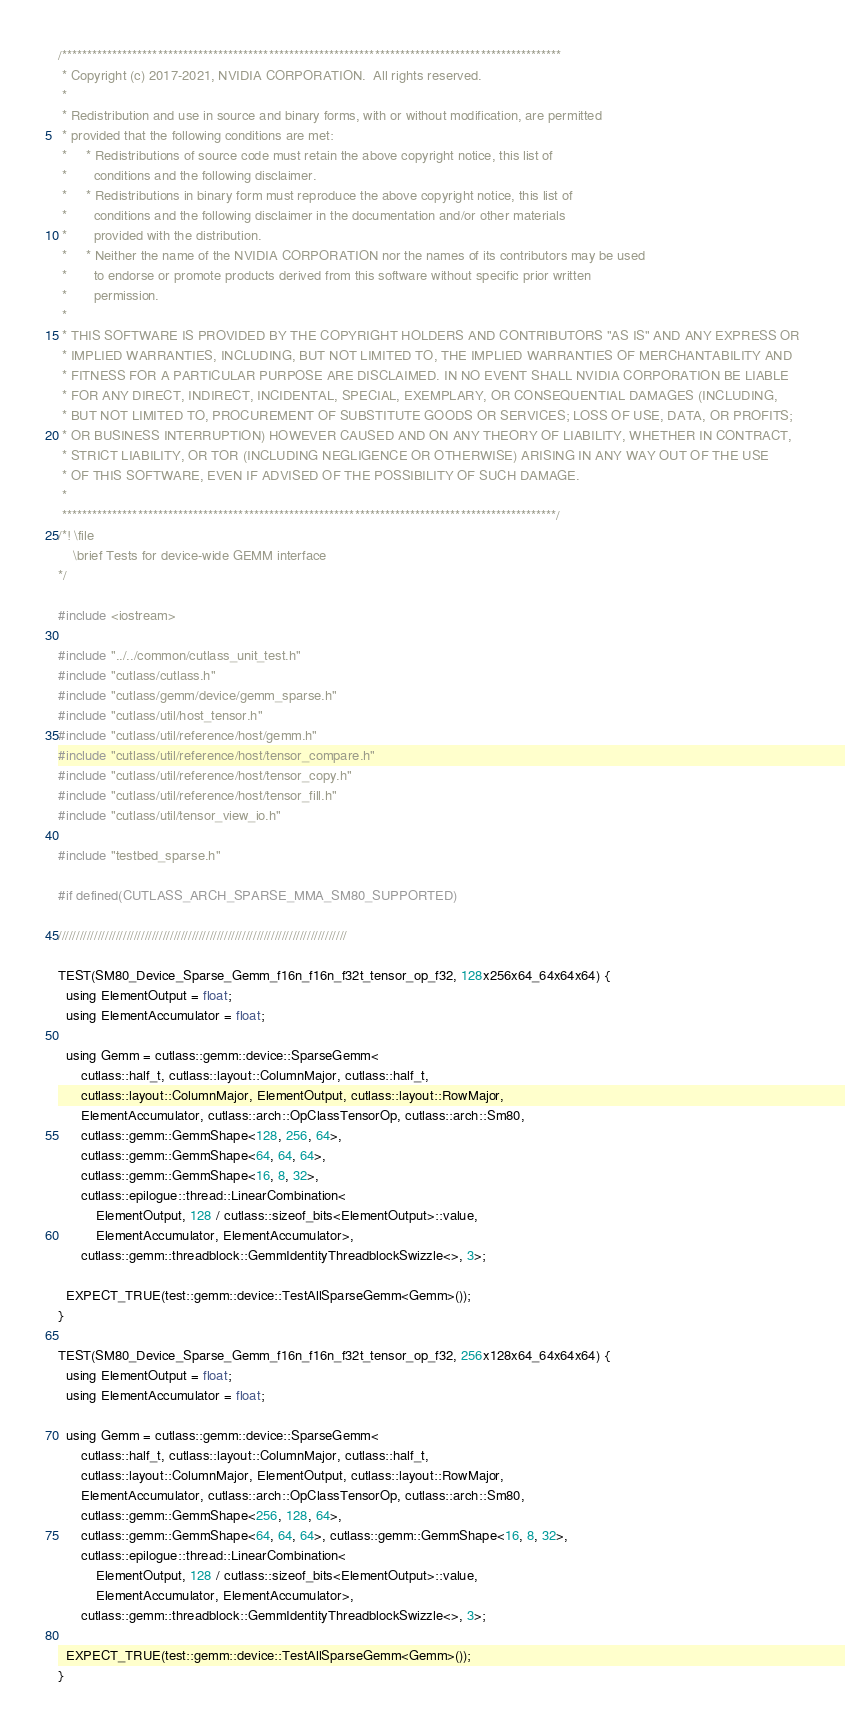Convert code to text. <code><loc_0><loc_0><loc_500><loc_500><_Cuda_>/***************************************************************************************************
 * Copyright (c) 2017-2021, NVIDIA CORPORATION.  All rights reserved.
 *
 * Redistribution and use in source and binary forms, with or without modification, are permitted
 * provided that the following conditions are met:
 *     * Redistributions of source code must retain the above copyright notice, this list of
 *       conditions and the following disclaimer.
 *     * Redistributions in binary form must reproduce the above copyright notice, this list of
 *       conditions and the following disclaimer in the documentation and/or other materials
 *       provided with the distribution.
 *     * Neither the name of the NVIDIA CORPORATION nor the names of its contributors may be used
 *       to endorse or promote products derived from this software without specific prior written
 *       permission.
 *
 * THIS SOFTWARE IS PROVIDED BY THE COPYRIGHT HOLDERS AND CONTRIBUTORS "AS IS" AND ANY EXPRESS OR
 * IMPLIED WARRANTIES, INCLUDING, BUT NOT LIMITED TO, THE IMPLIED WARRANTIES OF MERCHANTABILITY AND
 * FITNESS FOR A PARTICULAR PURPOSE ARE DISCLAIMED. IN NO EVENT SHALL NVIDIA CORPORATION BE LIABLE
 * FOR ANY DIRECT, INDIRECT, INCIDENTAL, SPECIAL, EXEMPLARY, OR CONSEQUENTIAL DAMAGES (INCLUDING,
 * BUT NOT LIMITED TO, PROCUREMENT OF SUBSTITUTE GOODS OR SERVICES; LOSS OF USE, DATA, OR PROFITS;
 * OR BUSINESS INTERRUPTION) HOWEVER CAUSED AND ON ANY THEORY OF LIABILITY, WHETHER IN CONTRACT,
 * STRICT LIABILITY, OR TOR (INCLUDING NEGLIGENCE OR OTHERWISE) ARISING IN ANY WAY OUT OF THE USE
 * OF THIS SOFTWARE, EVEN IF ADVISED OF THE POSSIBILITY OF SUCH DAMAGE.
 *
 **************************************************************************************************/
/*! \file
    \brief Tests for device-wide GEMM interface
*/

#include <iostream>

#include "../../common/cutlass_unit_test.h"
#include "cutlass/cutlass.h"
#include "cutlass/gemm/device/gemm_sparse.h"
#include "cutlass/util/host_tensor.h"
#include "cutlass/util/reference/host/gemm.h"
#include "cutlass/util/reference/host/tensor_compare.h"
#include "cutlass/util/reference/host/tensor_copy.h"
#include "cutlass/util/reference/host/tensor_fill.h"
#include "cutlass/util/tensor_view_io.h"

#include "testbed_sparse.h"

#if defined(CUTLASS_ARCH_SPARSE_MMA_SM80_SUPPORTED)

////////////////////////////////////////////////////////////////////////////////

TEST(SM80_Device_Sparse_Gemm_f16n_f16n_f32t_tensor_op_f32, 128x256x64_64x64x64) {
  using ElementOutput = float;
  using ElementAccumulator = float;

  using Gemm = cutlass::gemm::device::SparseGemm<
      cutlass::half_t, cutlass::layout::ColumnMajor, cutlass::half_t,
      cutlass::layout::ColumnMajor, ElementOutput, cutlass::layout::RowMajor,
      ElementAccumulator, cutlass::arch::OpClassTensorOp, cutlass::arch::Sm80,
      cutlass::gemm::GemmShape<128, 256, 64>,
      cutlass::gemm::GemmShape<64, 64, 64>,
      cutlass::gemm::GemmShape<16, 8, 32>,
      cutlass::epilogue::thread::LinearCombination<
          ElementOutput, 128 / cutlass::sizeof_bits<ElementOutput>::value,
          ElementAccumulator, ElementAccumulator>,
      cutlass::gemm::threadblock::GemmIdentityThreadblockSwizzle<>, 3>;

  EXPECT_TRUE(test::gemm::device::TestAllSparseGemm<Gemm>());
}

TEST(SM80_Device_Sparse_Gemm_f16n_f16n_f32t_tensor_op_f32, 256x128x64_64x64x64) {
  using ElementOutput = float;
  using ElementAccumulator = float;

  using Gemm = cutlass::gemm::device::SparseGemm<
      cutlass::half_t, cutlass::layout::ColumnMajor, cutlass::half_t,
      cutlass::layout::ColumnMajor, ElementOutput, cutlass::layout::RowMajor,
      ElementAccumulator, cutlass::arch::OpClassTensorOp, cutlass::arch::Sm80,
      cutlass::gemm::GemmShape<256, 128, 64>,
      cutlass::gemm::GemmShape<64, 64, 64>, cutlass::gemm::GemmShape<16, 8, 32>,
      cutlass::epilogue::thread::LinearCombination<
          ElementOutput, 128 / cutlass::sizeof_bits<ElementOutput>::value,
          ElementAccumulator, ElementAccumulator>,
      cutlass::gemm::threadblock::GemmIdentityThreadblockSwizzle<>, 3>;

  EXPECT_TRUE(test::gemm::device::TestAllSparseGemm<Gemm>());
}
</code> 